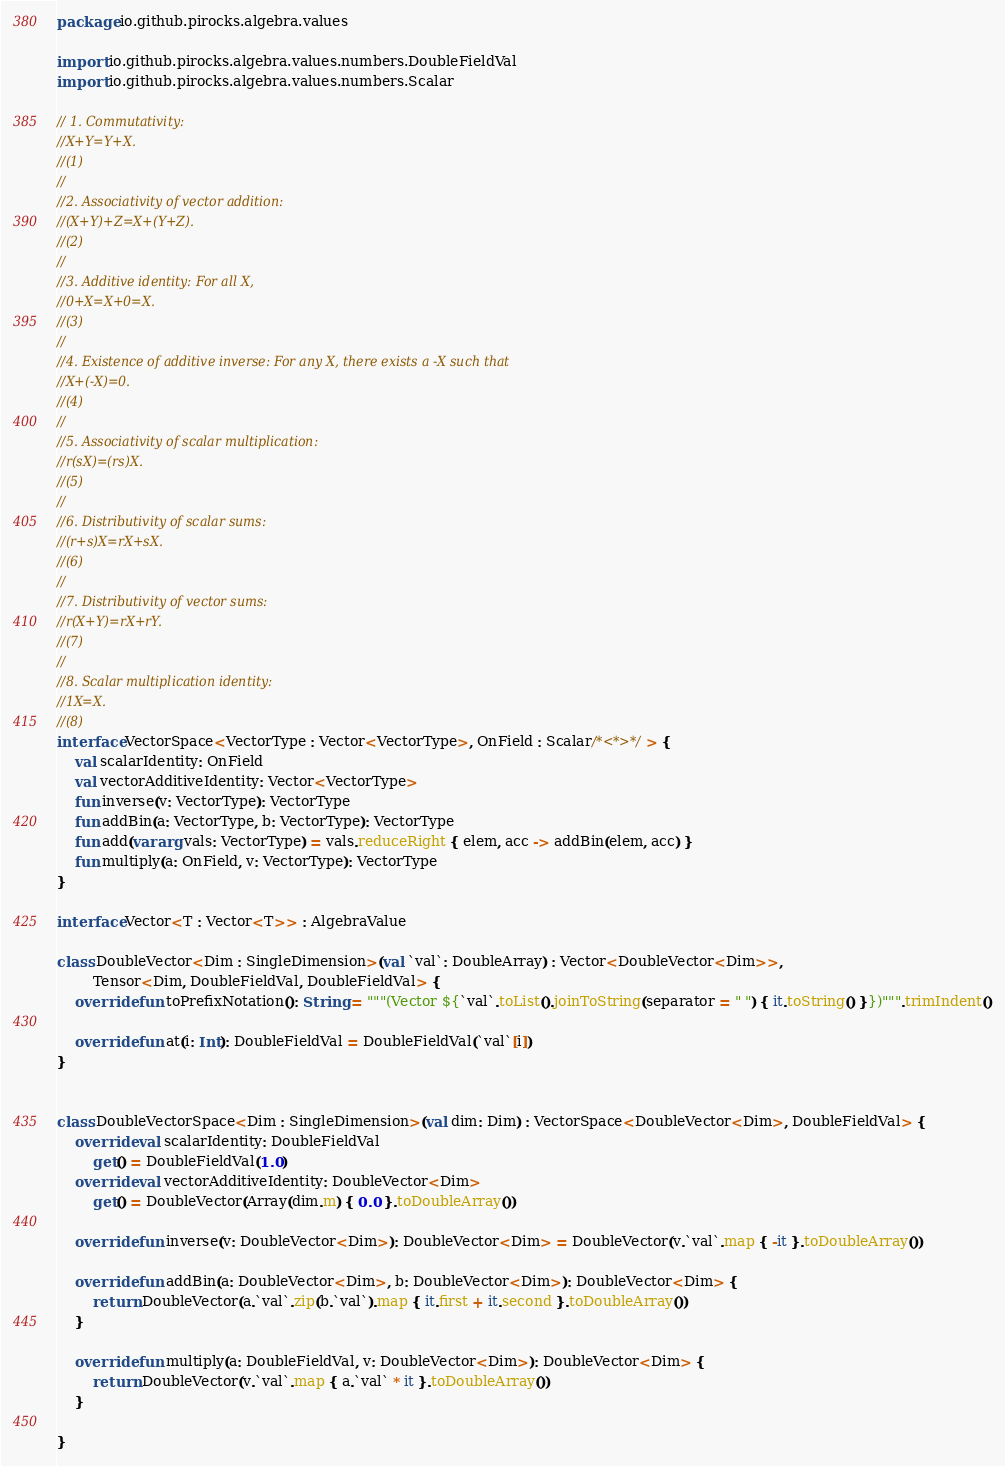Convert code to text. <code><loc_0><loc_0><loc_500><loc_500><_Kotlin_>package io.github.pirocks.algebra.values

import io.github.pirocks.algebra.values.numbers.DoubleFieldVal
import io.github.pirocks.algebra.values.numbers.Scalar

// 1. Commutativity:
//X+Y=Y+X.
//(1)
//
//2. Associativity of vector addition:
//(X+Y)+Z=X+(Y+Z).
//(2)
//
//3. Additive identity: For all X,
//0+X=X+0=X.
//(3)
//
//4. Existence of additive inverse: For any X, there exists a -X such that
//X+(-X)=0.
//(4)
//
//5. Associativity of scalar multiplication:
//r(sX)=(rs)X.
//(5)
//
//6. Distributivity of scalar sums:
//(r+s)X=rX+sX.
//(6)
//
//7. Distributivity of vector sums:
//r(X+Y)=rX+rY.
//(7)
//
//8. Scalar multiplication identity:
//1X=X.
//(8)
interface VectorSpace<VectorType : Vector<VectorType>, OnField : Scalar/*<*>*/> {
    val scalarIdentity: OnField
    val vectorAdditiveIdentity: Vector<VectorType>
    fun inverse(v: VectorType): VectorType
    fun addBin(a: VectorType, b: VectorType): VectorType
    fun add(vararg vals: VectorType) = vals.reduceRight { elem, acc -> addBin(elem, acc) }
    fun multiply(a: OnField, v: VectorType): VectorType
}

interface Vector<T : Vector<T>> : AlgebraValue

class DoubleVector<Dim : SingleDimension>(val `val`: DoubleArray) : Vector<DoubleVector<Dim>>,
        Tensor<Dim, DoubleFieldVal, DoubleFieldVal> {
    override fun toPrefixNotation(): String = """(Vector ${`val`.toList().joinToString(separator = " ") { it.toString() }})""".trimIndent()

    override fun at(i: Int): DoubleFieldVal = DoubleFieldVal(`val`[i])
}


class DoubleVectorSpace<Dim : SingleDimension>(val dim: Dim) : VectorSpace<DoubleVector<Dim>, DoubleFieldVal> {
    override val scalarIdentity: DoubleFieldVal
        get() = DoubleFieldVal(1.0)
    override val vectorAdditiveIdentity: DoubleVector<Dim>
        get() = DoubleVector(Array(dim.m) { 0.0 }.toDoubleArray())

    override fun inverse(v: DoubleVector<Dim>): DoubleVector<Dim> = DoubleVector(v.`val`.map { -it }.toDoubleArray())

    override fun addBin(a: DoubleVector<Dim>, b: DoubleVector<Dim>): DoubleVector<Dim> {
        return DoubleVector(a.`val`.zip(b.`val`).map { it.first + it.second }.toDoubleArray())
    }

    override fun multiply(a: DoubleFieldVal, v: DoubleVector<Dim>): DoubleVector<Dim> {
        return DoubleVector(v.`val`.map { a.`val` * it }.toDoubleArray())
    }

}
</code> 